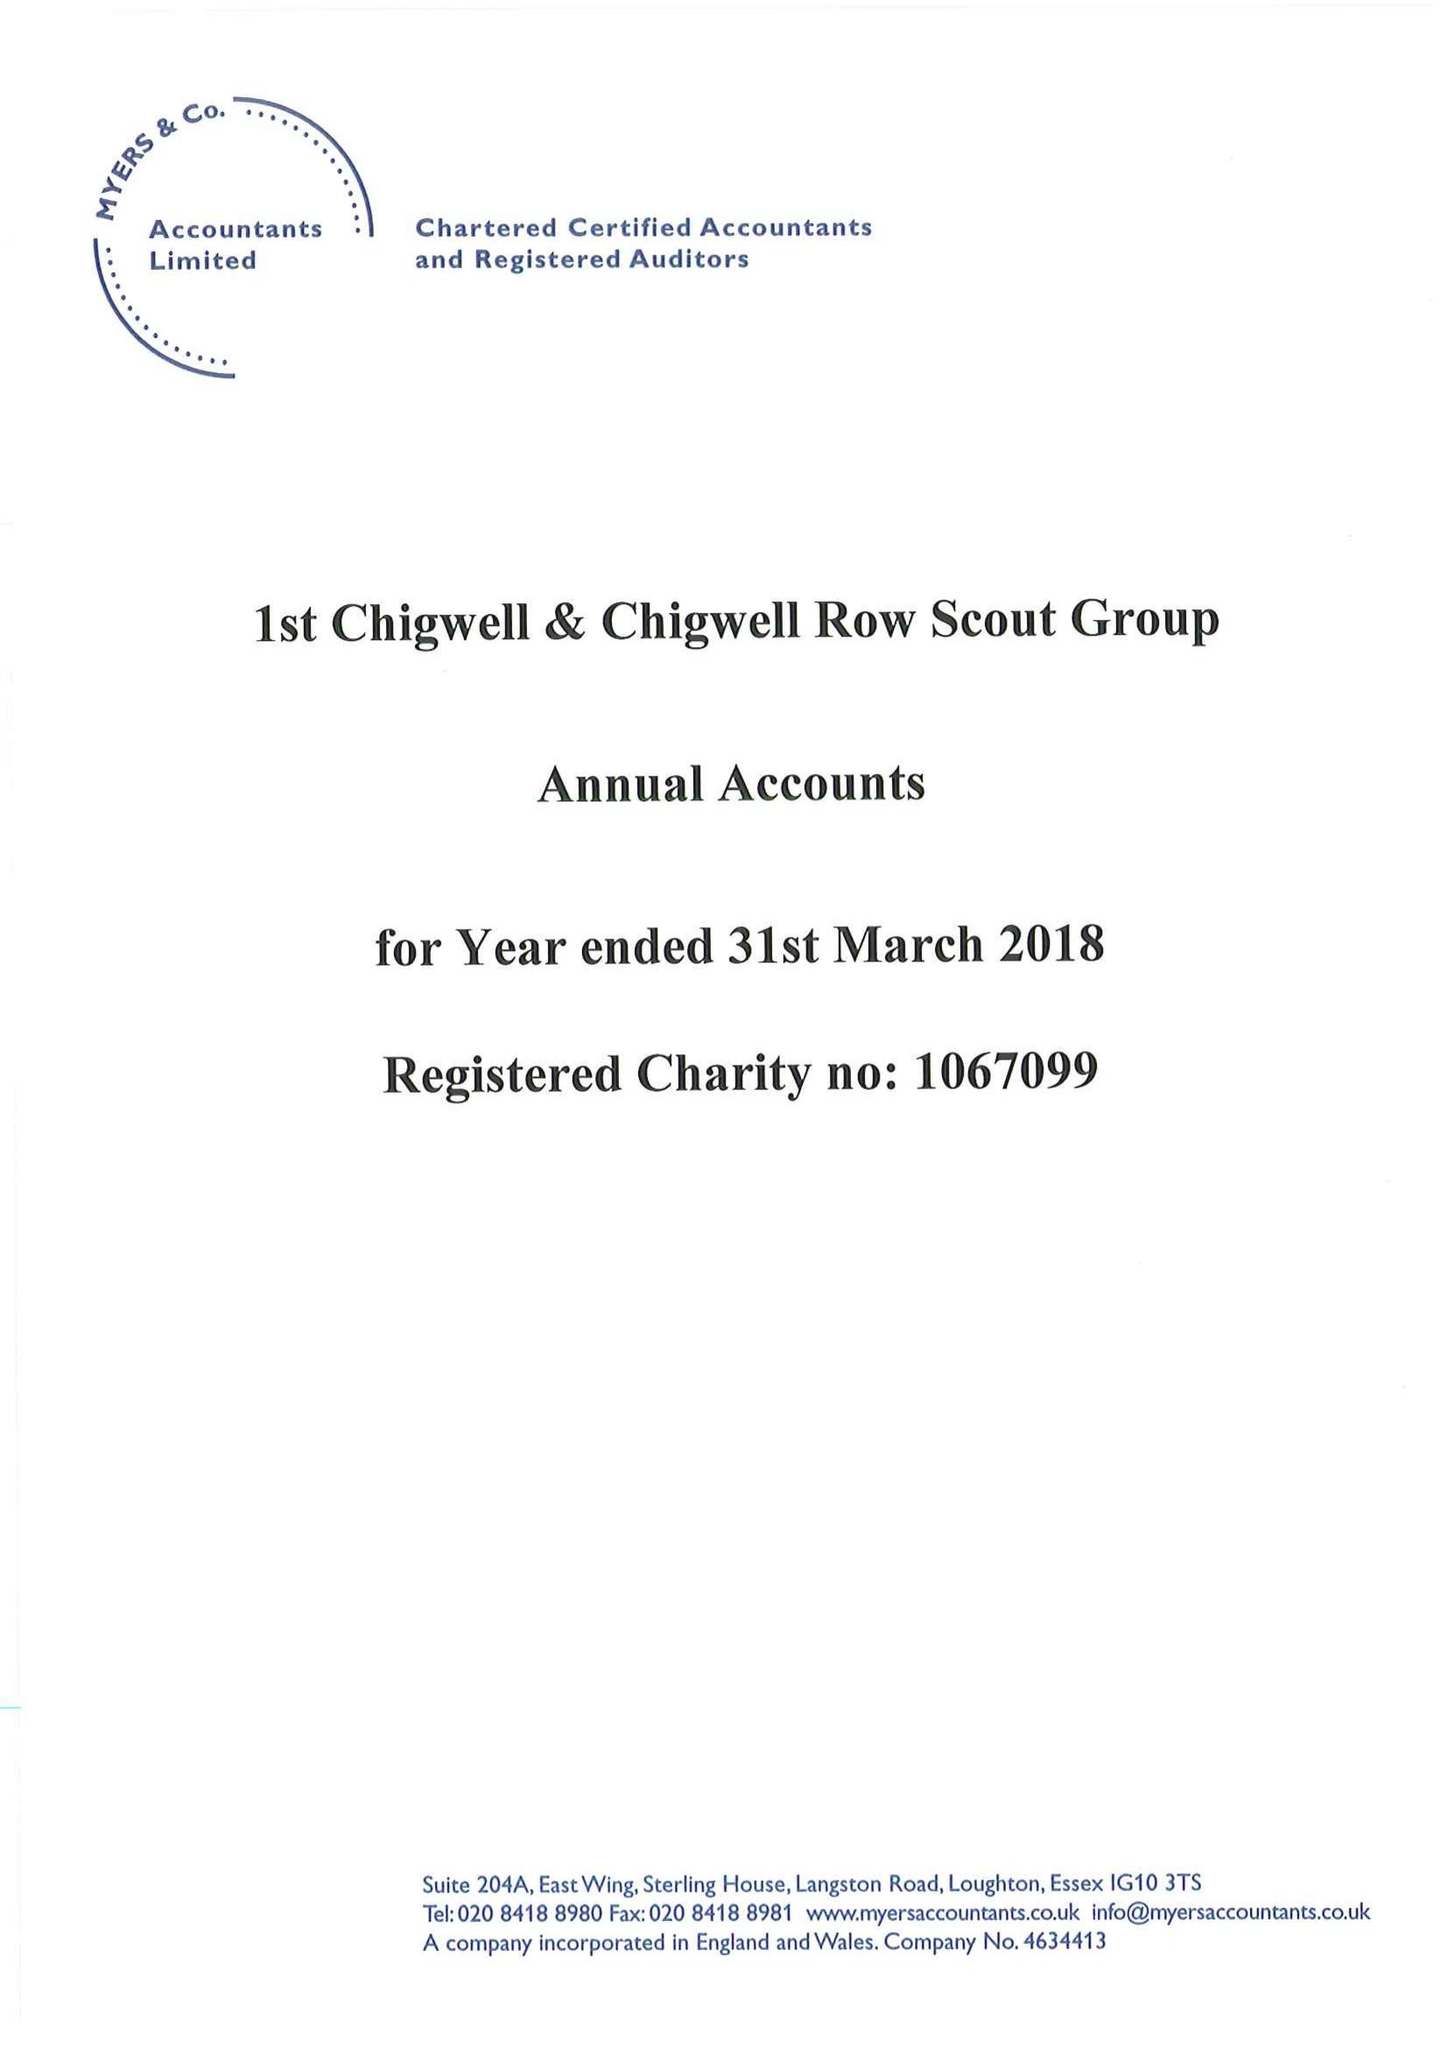What is the value for the report_date?
Answer the question using a single word or phrase. 2018-03-31 